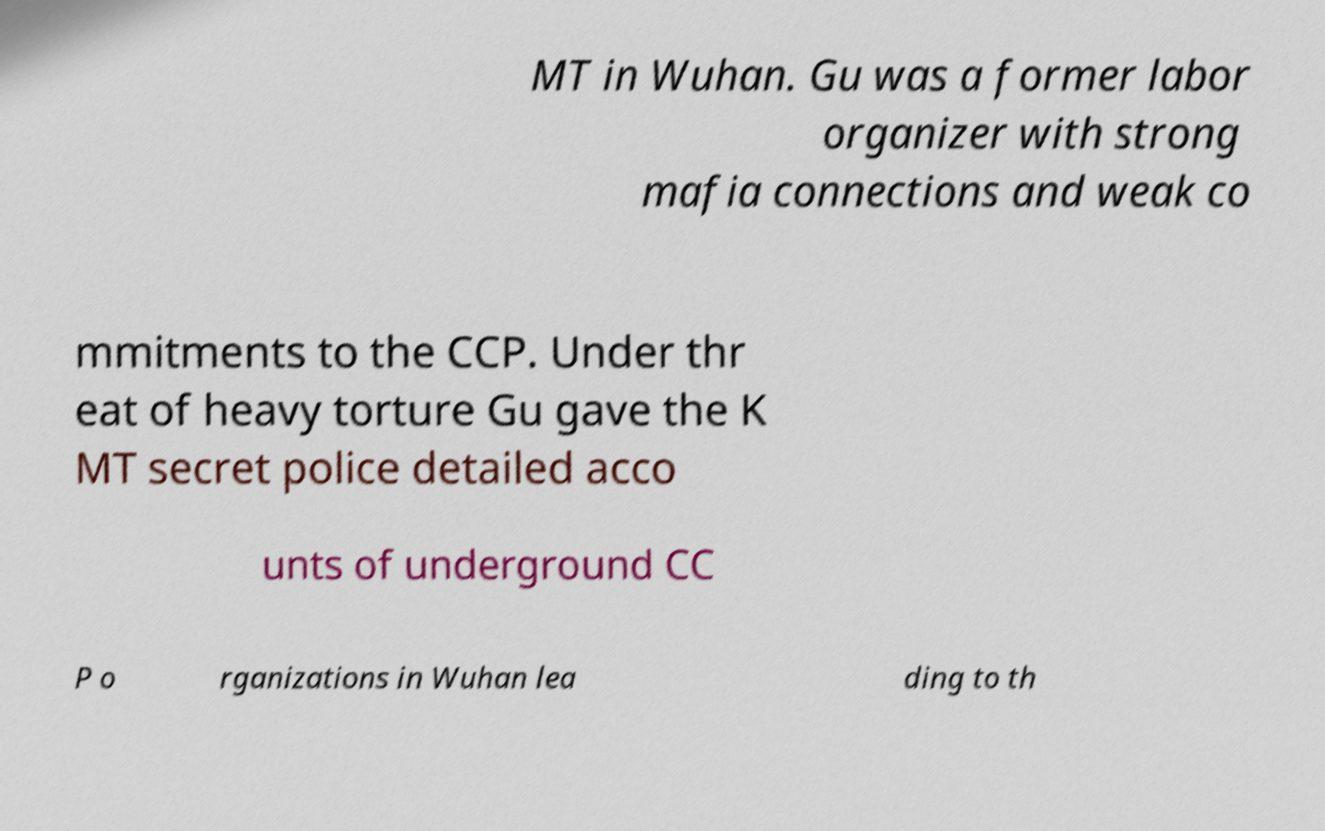Please read and relay the text visible in this image. What does it say? MT in Wuhan. Gu was a former labor organizer with strong mafia connections and weak co mmitments to the CCP. Under thr eat of heavy torture Gu gave the K MT secret police detailed acco unts of underground CC P o rganizations in Wuhan lea ding to th 